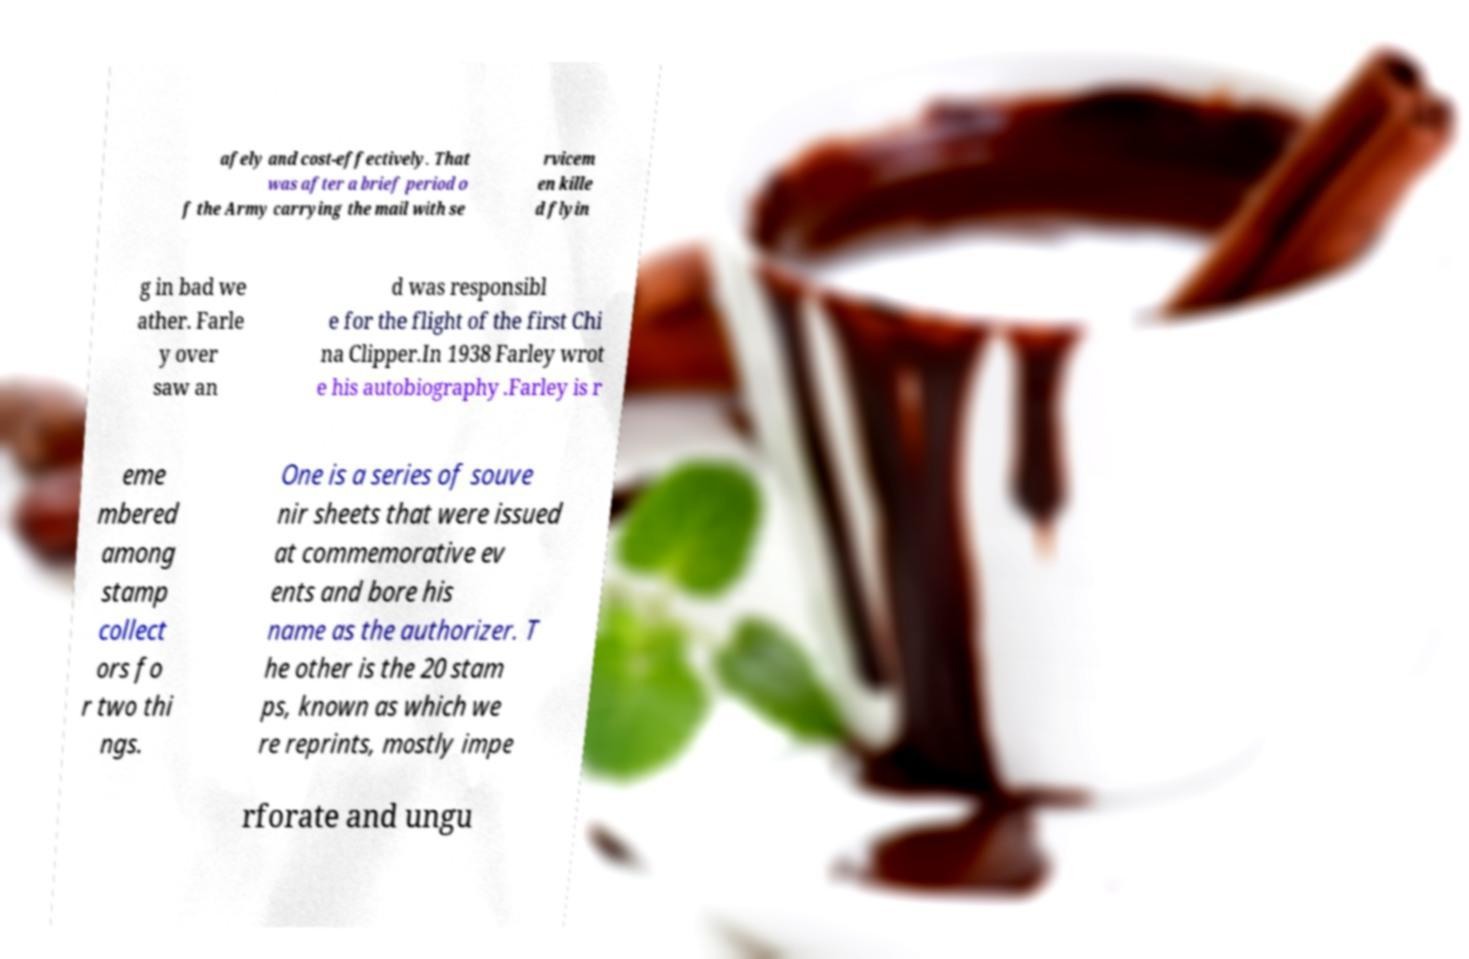Please identify and transcribe the text found in this image. afely and cost-effectively. That was after a brief period o f the Army carrying the mail with se rvicem en kille d flyin g in bad we ather. Farle y over saw an d was responsibl e for the flight of the first Chi na Clipper.In 1938 Farley wrot e his autobiography .Farley is r eme mbered among stamp collect ors fo r two thi ngs. One is a series of souve nir sheets that were issued at commemorative ev ents and bore his name as the authorizer. T he other is the 20 stam ps, known as which we re reprints, mostly impe rforate and ungu 